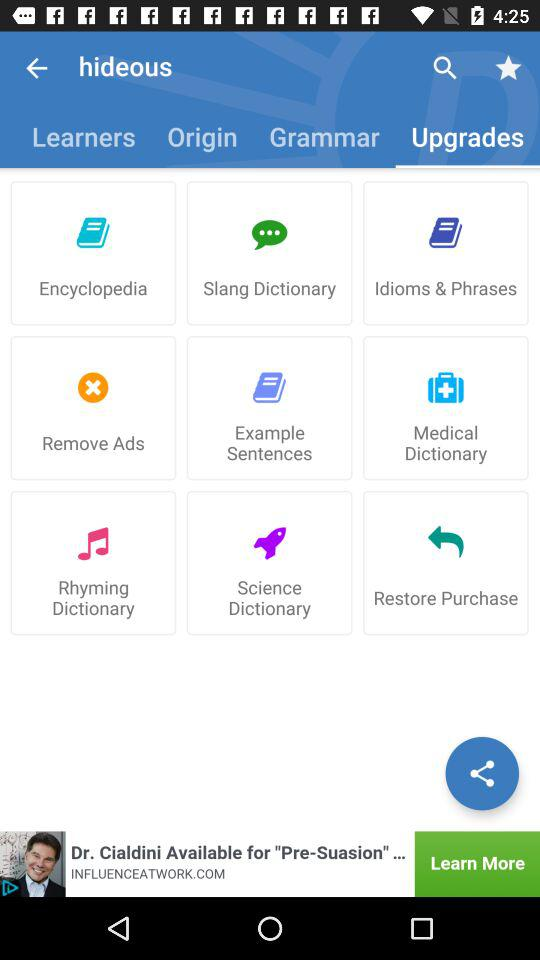Which tab am I on? You are on the "Upgrades" tab. 